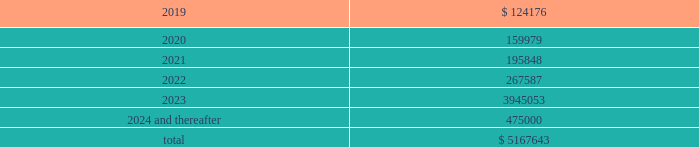Maturity requirements on long-term debt as of december 31 , 2018 by year are as follows ( in thousands ) : years ending december 31 .
Credit facility we are party to a credit facility agreement with bank of america , n.a. , as administrative agent , and a syndicate of financial institutions as lenders and other agents ( as amended from time to time , the 201ccredit facility 201d ) .
As of december 31 , 2018 , the credit facility provided for secured financing comprised of ( i ) a $ 1.5 billion revolving credit facility ( the 201crevolving credit facility 201d ) ; ( ii ) a $ 1.5 billion term loan ( the 201cterm a loan 201d ) , ( iii ) a $ 1.37 billion term loan ( the 201cterm a-2 loan 201d ) , ( iv ) a $ 1.14 billion term loan facility ( the 201cterm b-2 loan 201d ) and ( v ) a $ 500 million term loan ( the 201cterm b-4 loan 201d ) .
Substantially all of the assets of our domestic subsidiaries are pledged as collateral under the credit facility .
The borrowings outstanding under our credit facility as of december 31 , 2018 reflect amounts borrowed for acquisitions and other activities we completed in 2018 , including a reduction to the interest rate margins applicable to our term a loan , term a-2 loan , term b-2 loan and the revolving credit facility , an extension of the maturity dates of the term a loan , term a-2 loan and the revolving credit facility , and an increase in the total financing capacity under the credit facility to approximately $ 5.5 billion in june 2018 .
In october 2018 , we entered into an additional term loan under the credit facility in the amount of $ 500 million ( the 201cterm b-4 loan 201d ) .
We used the proceeds from the term b-4 loan to pay down a portion of the balance outstanding under our revolving credit facility .
The credit facility provides for an interest rate , at our election , of either libor or a base rate , in each case plus a margin .
As of december 31 , 2018 , the interest rates on the term a loan , the term a-2 loan , the term b-2 loan and the term b-4 loan were 4.02% ( 4.02 % ) , 4.01% ( 4.01 % ) , 4.27% ( 4.27 % ) and 4.27% ( 4.27 % ) , respectively , and the interest rate on the revolving credit facility was 3.92% ( 3.92 % ) .
In addition , we are required to pay a quarterly commitment fee with respect to the unused portion of the revolving credit facility at an applicable rate per annum ranging from 0.20% ( 0.20 % ) to 0.30% ( 0.30 % ) depending on our leverage ratio .
The term a loan and the term a-2 loan mature , and the revolving credit facility expires , on january 20 , 2023 .
The term b-2 loan matures on april 22 , 2023 .
The term b-4 loan matures on october 18 , 2025 .
The term a loan and term a-2 loan principal amounts must each be repaid in quarterly installments in the amount of 0.625% ( 0.625 % ) of principal through june 2019 , increasing to 1.25% ( 1.25 % ) of principal through june 2021 , increasing to 1.875% ( 1.875 % ) of principal through june 2022 and increasing to 2.50% ( 2.50 % ) of principal through december 2022 , with the remaining principal balance due upon maturity in january 2023 .
The term b-2 loan principal must be repaid in quarterly installments in the amount of 0.25% ( 0.25 % ) of principal through march 2023 , with the remaining principal balance due upon maturity in april 2023 .
The term b-4 loan principal must be repaid in quarterly installments in the amount of 0.25% ( 0.25 % ) of principal through september 2025 , with the remaining principal balance due upon maturity in october 2025 .
We may issue standby letters of credit of up to $ 100 million in the aggregate under the revolving credit facility .
Outstanding letters of credit under the revolving credit facility reduce the amount of borrowings available to us .
Borrowings available to us under the revolving credit facility are further limited by the covenants described below under 201ccompliance with covenants . 201d the total available commitments under the revolving credit facility at december 31 , 2018 were $ 783.6 million .
Global payments inc .
| 2018 form 10-k annual report 2013 85 .
What is the yearly interest expense incurred from term a loan , ( in millions ) ? 
Computations: ((1.5 * 1000) * 4.02%)
Answer: 60.3. 